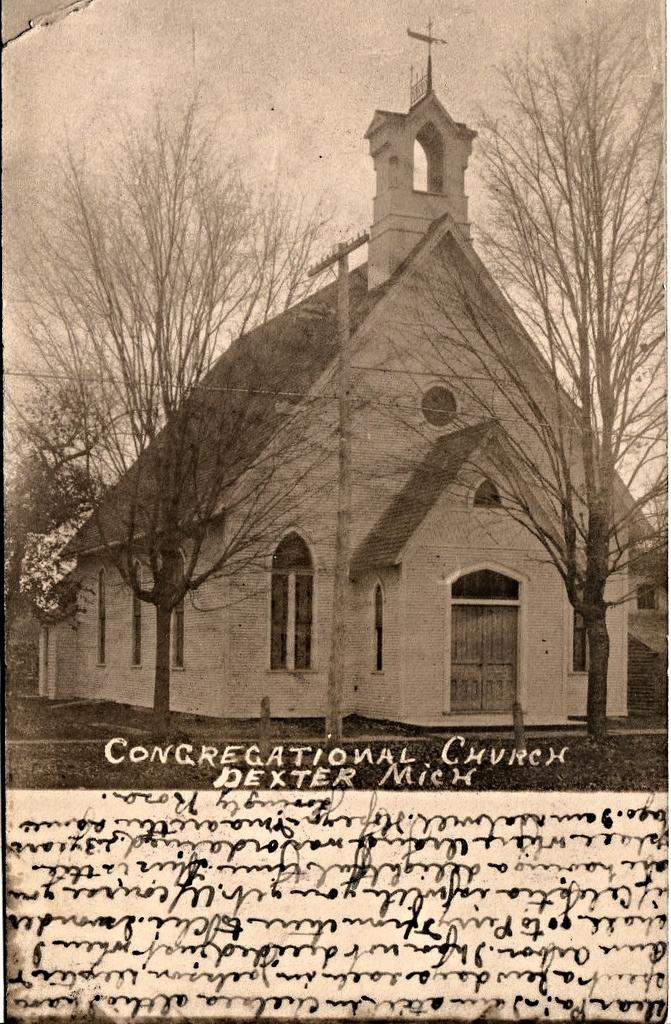Provide a one-sentence caption for the provided image. Vintage photo of the Congregational Church in Dixter Michigan. 